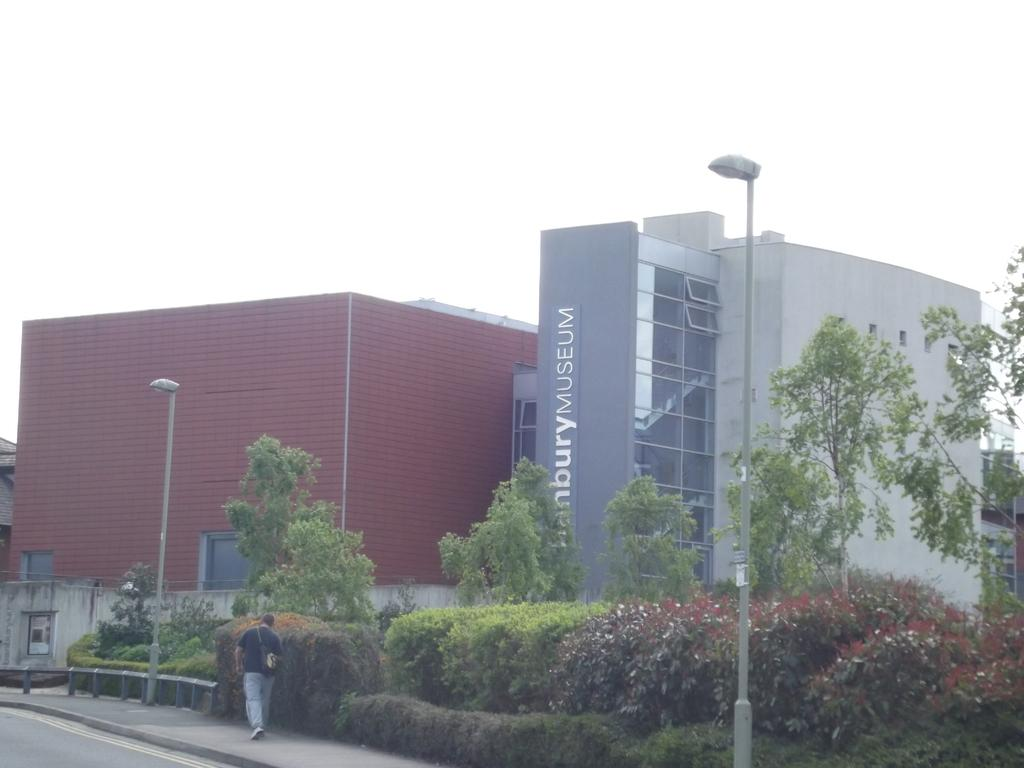What type of vegetation can be seen in the image? There are bushes and trees in the image. What type of structures are present in the image? There are buildings in the image. What type of infrastructure can be seen in the image? There are poles and street lights in the image. Is there any text visible in the image? Yes, there is text visible in the image. Can you describe the person in the image? There is a person standing in the image. What is the governor's opinion on the profit margin of the street lights in the image? There is no governor present in the image, nor is there any information about profit margins or opinions. 